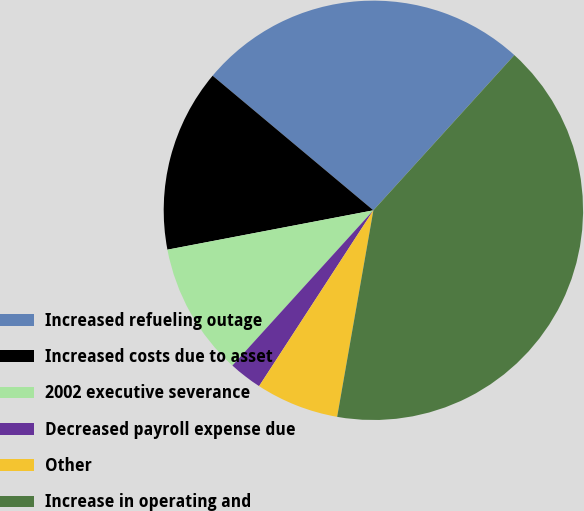Convert chart to OTSL. <chart><loc_0><loc_0><loc_500><loc_500><pie_chart><fcel>Increased refueling outage<fcel>Increased costs due to asset<fcel>2002 executive severance<fcel>Decreased payroll expense due<fcel>Other<fcel>Increase in operating and<nl><fcel>25.64%<fcel>14.1%<fcel>10.26%<fcel>2.56%<fcel>6.41%<fcel>41.03%<nl></chart> 